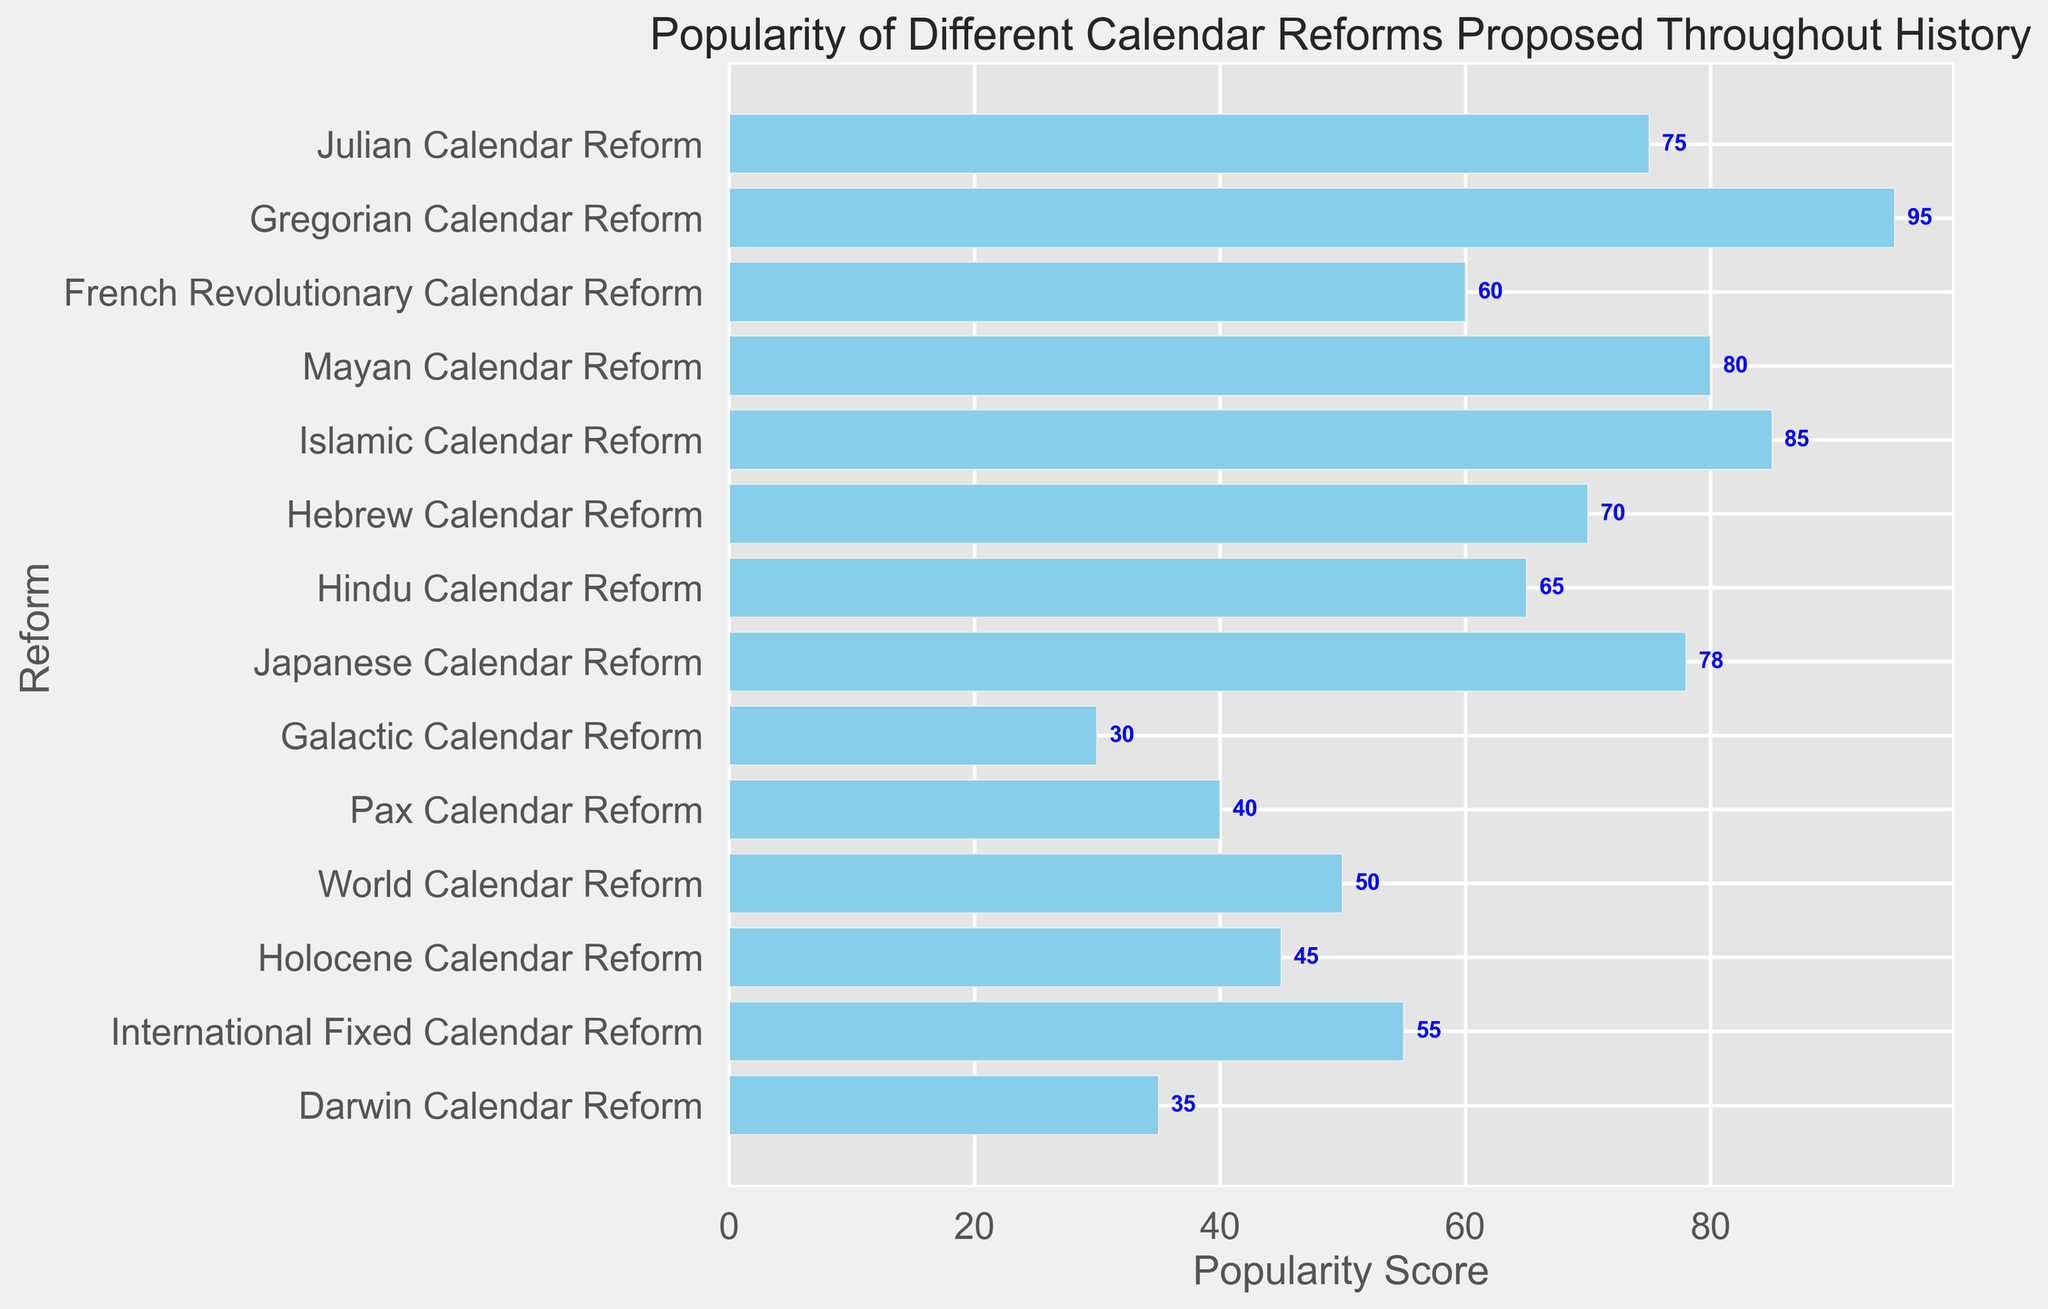Which calendar reform has the highest popularity score? To determine which calendar reform has the highest popularity score, look for the longest bar in the chart and check its label. The Gregorian Calendar Reform has the longest bar with a score of 95.
Answer: Gregorian Calendar Reform Which calendar reform has a higher popularity score, the Mayan Calendar Reform or the Islamic Calendar Reform? Compare the lengths of the bars for Mayan Calendar Reform (80) and Islamic Calendar Reform (85). The Islamic Calendar Reform's bar is longer, indicating a higher score.
Answer: Islamic Calendar Reform What is the total popularity score of the Julian, Hebrew, and Hindu Calendar Reforms combined? Add the popularity scores of Julian (75), Hebrew (70), and Hindu (65) Calendar Reforms together: 75 + 70 + 65 = 210.
Answer: 210 Which reform has a lower popularity score, the Pax Calendar Reform or the International Fixed Calendar Reform? Compare the bars for Pax Calendar Reform (40) and International Fixed Calendar Reform (55). The Pax Calendar Reform's bar is shorter, indicating a lower score.
Answer: Pax Calendar Reform How much higher is the popularity score of the Japanese Calendar Reform compared to the French Revolutionary Calendar Reform? Subtract the popularity score of the French Revolutionary Calendar Reform (60) from the Japanese Calendar Reform (78): 78 - 60 = 18.
Answer: 18 Which calendar reform is more popular, the Holocene Calendar Reform or the World Calendar Reform? Compare the bars for Holocene Calendar Reform (45) and World Calendar Reform (50). The World Calendar Reform's bar is longer, indicating higher popularity.
Answer: World Calendar Reform What is the average popularity score of the top three most popular calendar reforms? Identify the top three: Gregorian (95), Islamic (85), and Mayan (80). Add their scores and divide by 3: (95 + 85 + 80) / 3 = 260 / 3 ≈ 86.67.
Answer: 86.67 Which calendar reform has the shortest bar on the chart? The shortest bar on the chart corresponds to the Galactic Calendar Reform with a score of 30.
Answer: Galactic Calendar Reform 